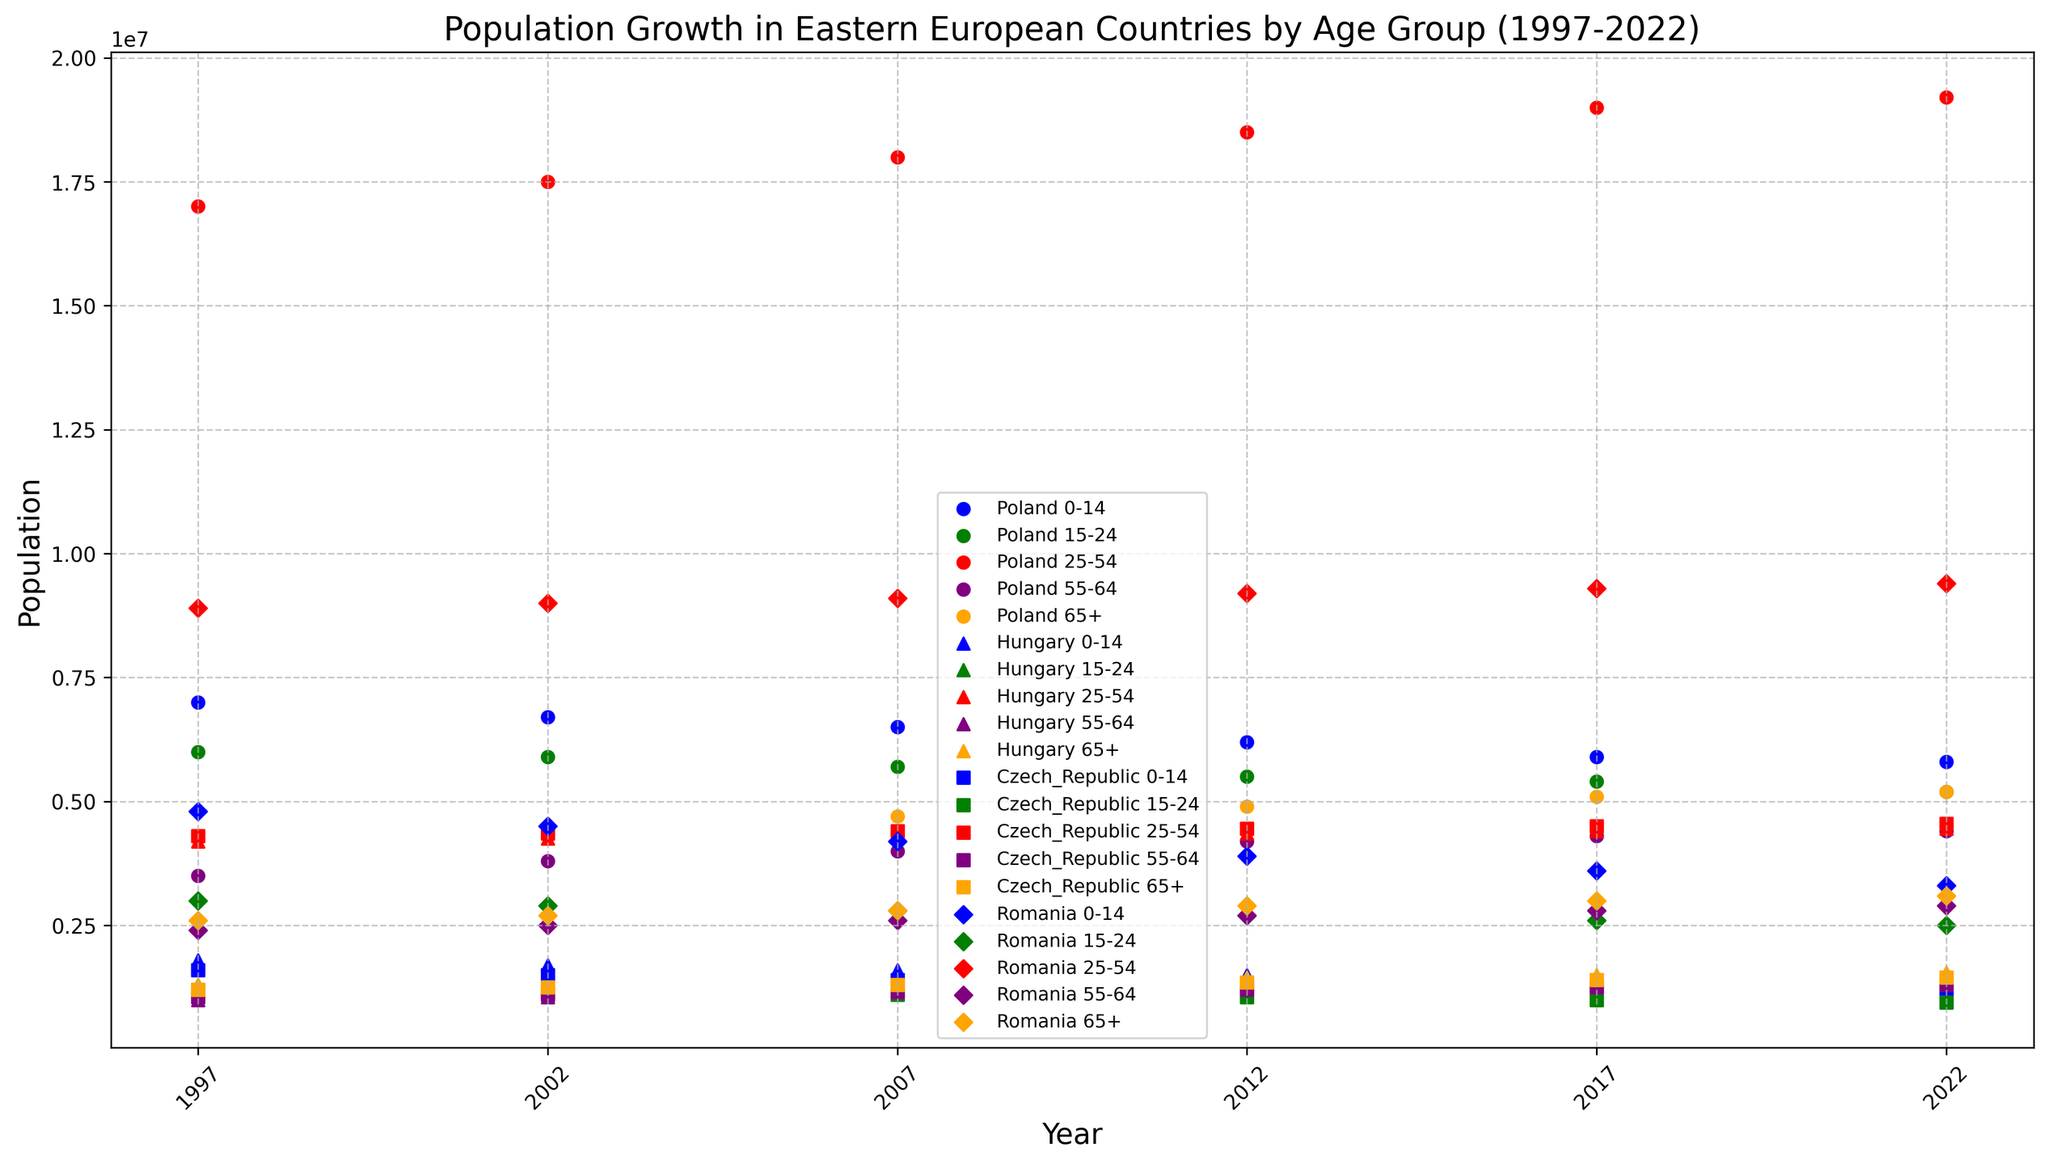Which country had the highest population in the 0-14 age group in 2022? Identify the data points for the year 2022 in the figure. Then check the y-values for the 0-14 age group indicated by blue markers. The country with the highest y-value for blue markers has the highest population for this age group.
Answer: Poland Which age group in Hungary shows a consistent population decrease from 1997 to 2022? Locate the green markers representing Hungary. Compare the y-values from 1997 to 2022 for each respective age group. The age group with consistently decreasing y-values is the answer.
Answer: 0-14 What is the total population for the 65+ age group across all countries in 2022? Extract the y-values for the 65+ age group for each country in 2022, indicated by the orange markers. Sum the y-values to get the total population.
Answer: 11,300,000 Which country had the lowest population in the 15-24 age group in 2007? Identify the data points for the year 2007 and look for green markers, which represent the 15-24 age group. Find the country with the lowest y-value.
Answer: Czech Republic Did the population of the 55-64 age group in Poland increase or decrease from 1997 to 2022? Examine the purple markers representing Poland from 1997 to 2022. Compare the y-values of these markers in 1997 and 2022 to determine if there was an increase or decrease.
Answer: Increase Between Poland and Romania, which country had a higher 25-54 age group population in 2012? Look at the red markers for the year 2012 for both Poland and Romania. Compare the y-values to determine which country has a higher population.
Answer: Poland What is the average population for the 0-14 age group in Czech Republic from 1997 to 2022? Locate the blue markers for the Czech Republic across all years. Sum the y-values and divide by the number of data points to find the average.
Answer: 1,325,000 Which age group in Romania saw the smallest change in population from 1997 to 2022? Compare the differences in y-values from 1997 to 2022 for all age groups in Romania. The age group with the smallest difference has the smallest change in population.
Answer: 25-54 What trend do you observe for the 65+ age group in Poland from 1997 to 2022? Analyze the y-values of the orange markers representing Poland from 1997 to 2022. Check if the values are increasing, decreasing, or remaining constant over the years to identify the trend.
Answer: Increasing 